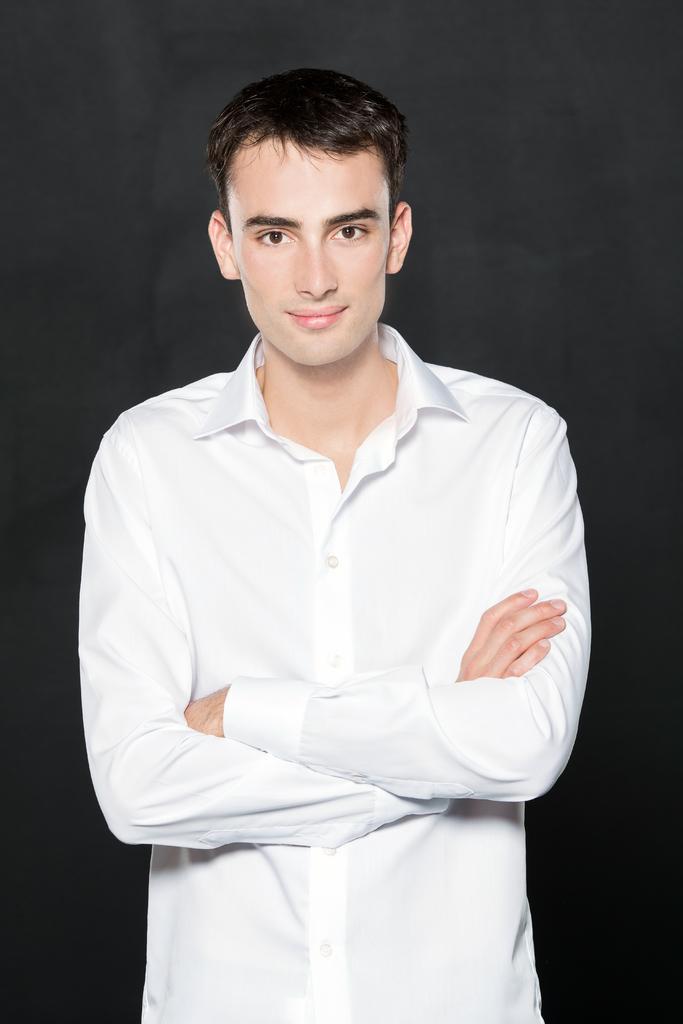Please provide a concise description of this image. In this image, we can see a person and the dark background. 